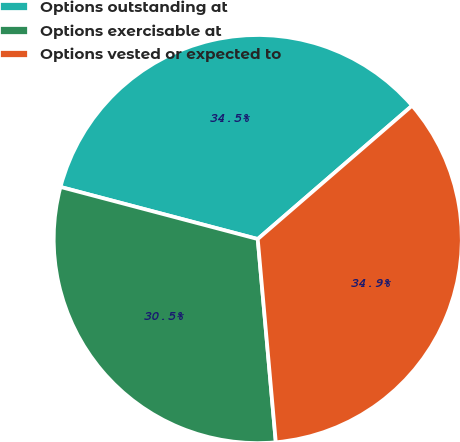<chart> <loc_0><loc_0><loc_500><loc_500><pie_chart><fcel>Options outstanding at<fcel>Options exercisable at<fcel>Options vested or expected to<nl><fcel>34.55%<fcel>30.52%<fcel>34.93%<nl></chart> 